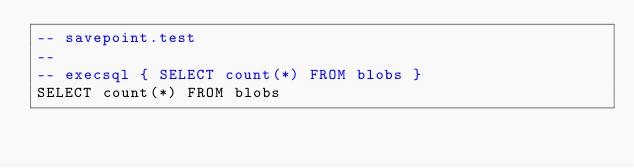<code> <loc_0><loc_0><loc_500><loc_500><_SQL_>-- savepoint.test
-- 
-- execsql { SELECT count(*) FROM blobs }
SELECT count(*) FROM blobs</code> 